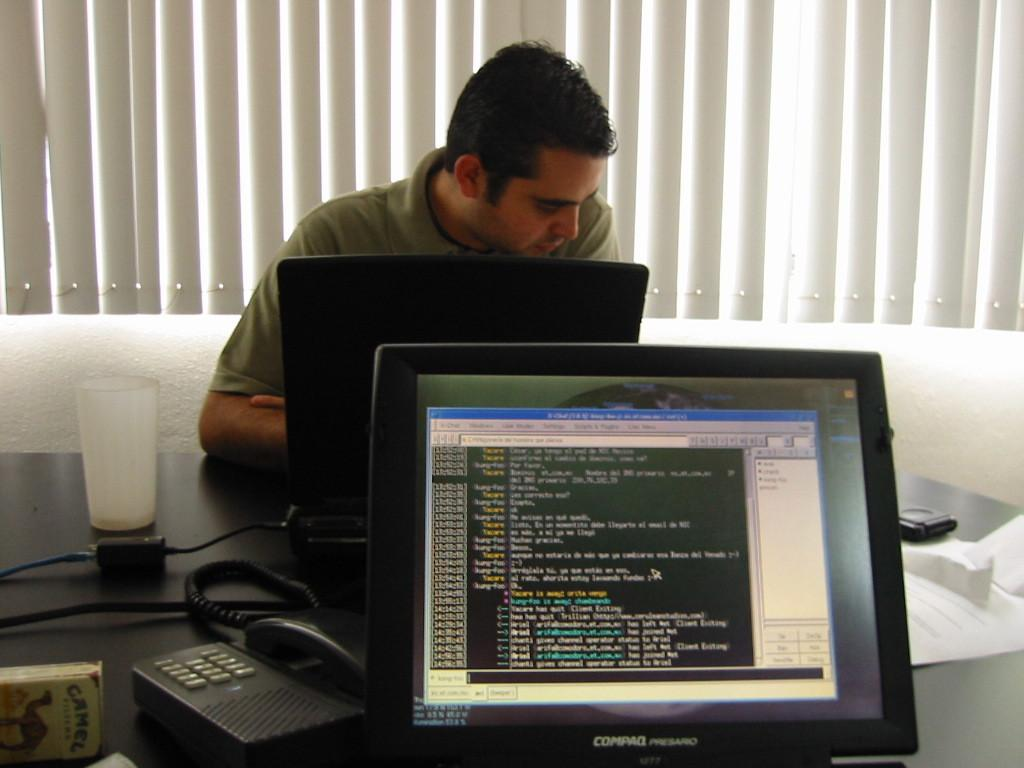What is the main piece of furniture in the image? There is a table in the image. What electronic devices are on the table? The table has a laptop and a desktop on it. What communication device is on the table? The table has a telephone on it. Are there any other objects on the table? Yes, there are other objects on the table. Can you describe the person in the background of the image? There is a person in the background of the image, but no specific details are provided. What other objects can be seen in the background of the image? There are other objects in the background of the image, but no specific details are provided. How many frogs are jumping on the table in the image? There are no frogs present in the image. What type of trucks can be seen driving through the background of the image? There are no trucks visible in the background of the image. 